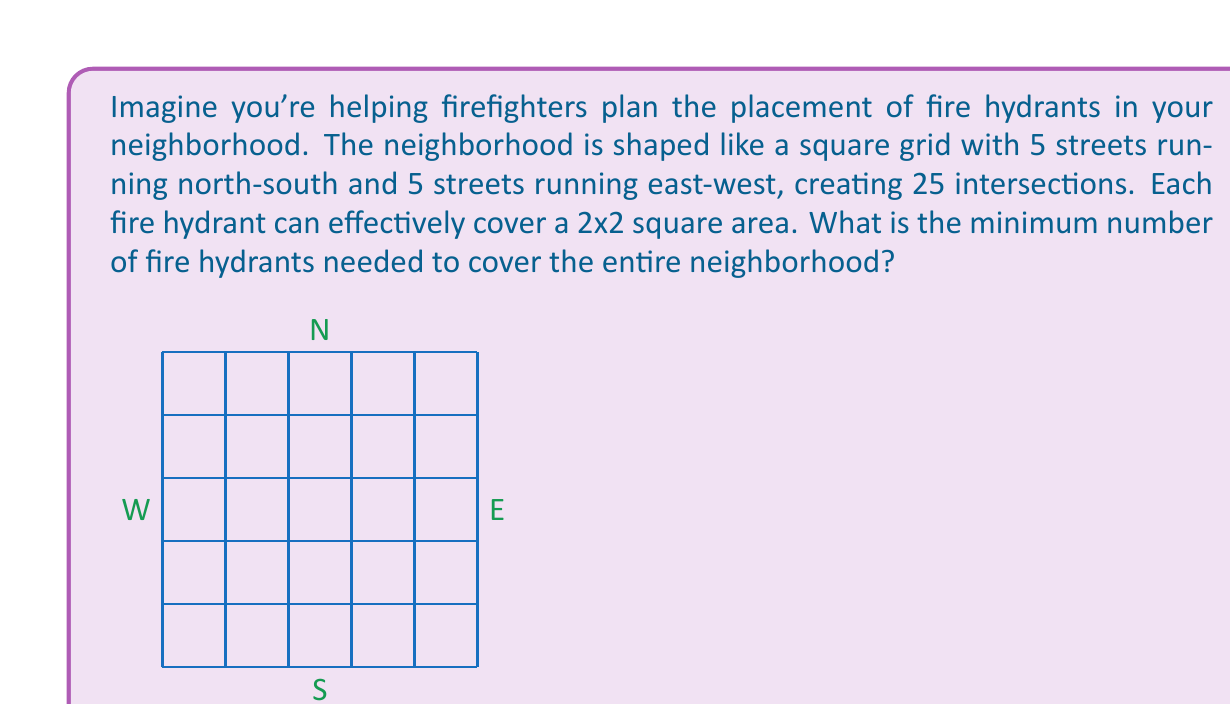Teach me how to tackle this problem. Let's approach this step-by-step:

1) First, we need to understand what the question is asking. We have a 5x5 grid of intersections, and each fire hydrant can cover a 2x2 area.

2) To minimize the number of hydrants, we want to place them in a way that maximizes coverage without overlap.

3) Let's start by placing a hydrant at the northwest corner. It will cover a 2x2 area:

   [asy]
   unitsize(1cm);
   for(int i=0; i<6; ++i) {
     draw((0,i)--(5,i));
     draw((i,0)--(i,5));
   }
   fill((0,3)--(2,3)--(2,5)--(0,5)--cycle, rgb(0.7,0.7,1));
   dot((0,5), red);
   [/asy]

4) We can place the next hydrant 2 intersections to the right of the first one:

   [asy]
   unitsize(1cm);
   for(int i=0; i<6; ++i) {
     draw((0,i)--(5,i));
     draw((i,0)--(i,5));
   }
   fill((0,3)--(2,3)--(2,5)--(0,5)--cycle, rgb(0.7,0.7,1));
   fill((2,3)--(4,3)--(4,5)--(2,5)--cycle, rgb(0.7,0.7,1));
   dot((0,5), red);
   dot((2,5), red);
   [/asy]

5) We can continue this pattern, placing hydrants every 2 intersections horizontally and vertically.

6) In total, we'll need 3 rows of hydrants, with 3 hydrants in each row.

7) Therefore, the total number of hydrants needed is $3 \times 3 = 9$.

This arrangement ensures that every intersection is covered by at least one hydrant, using the minimum number of hydrants possible.
Answer: The minimum number of fire hydrants needed is 9. 